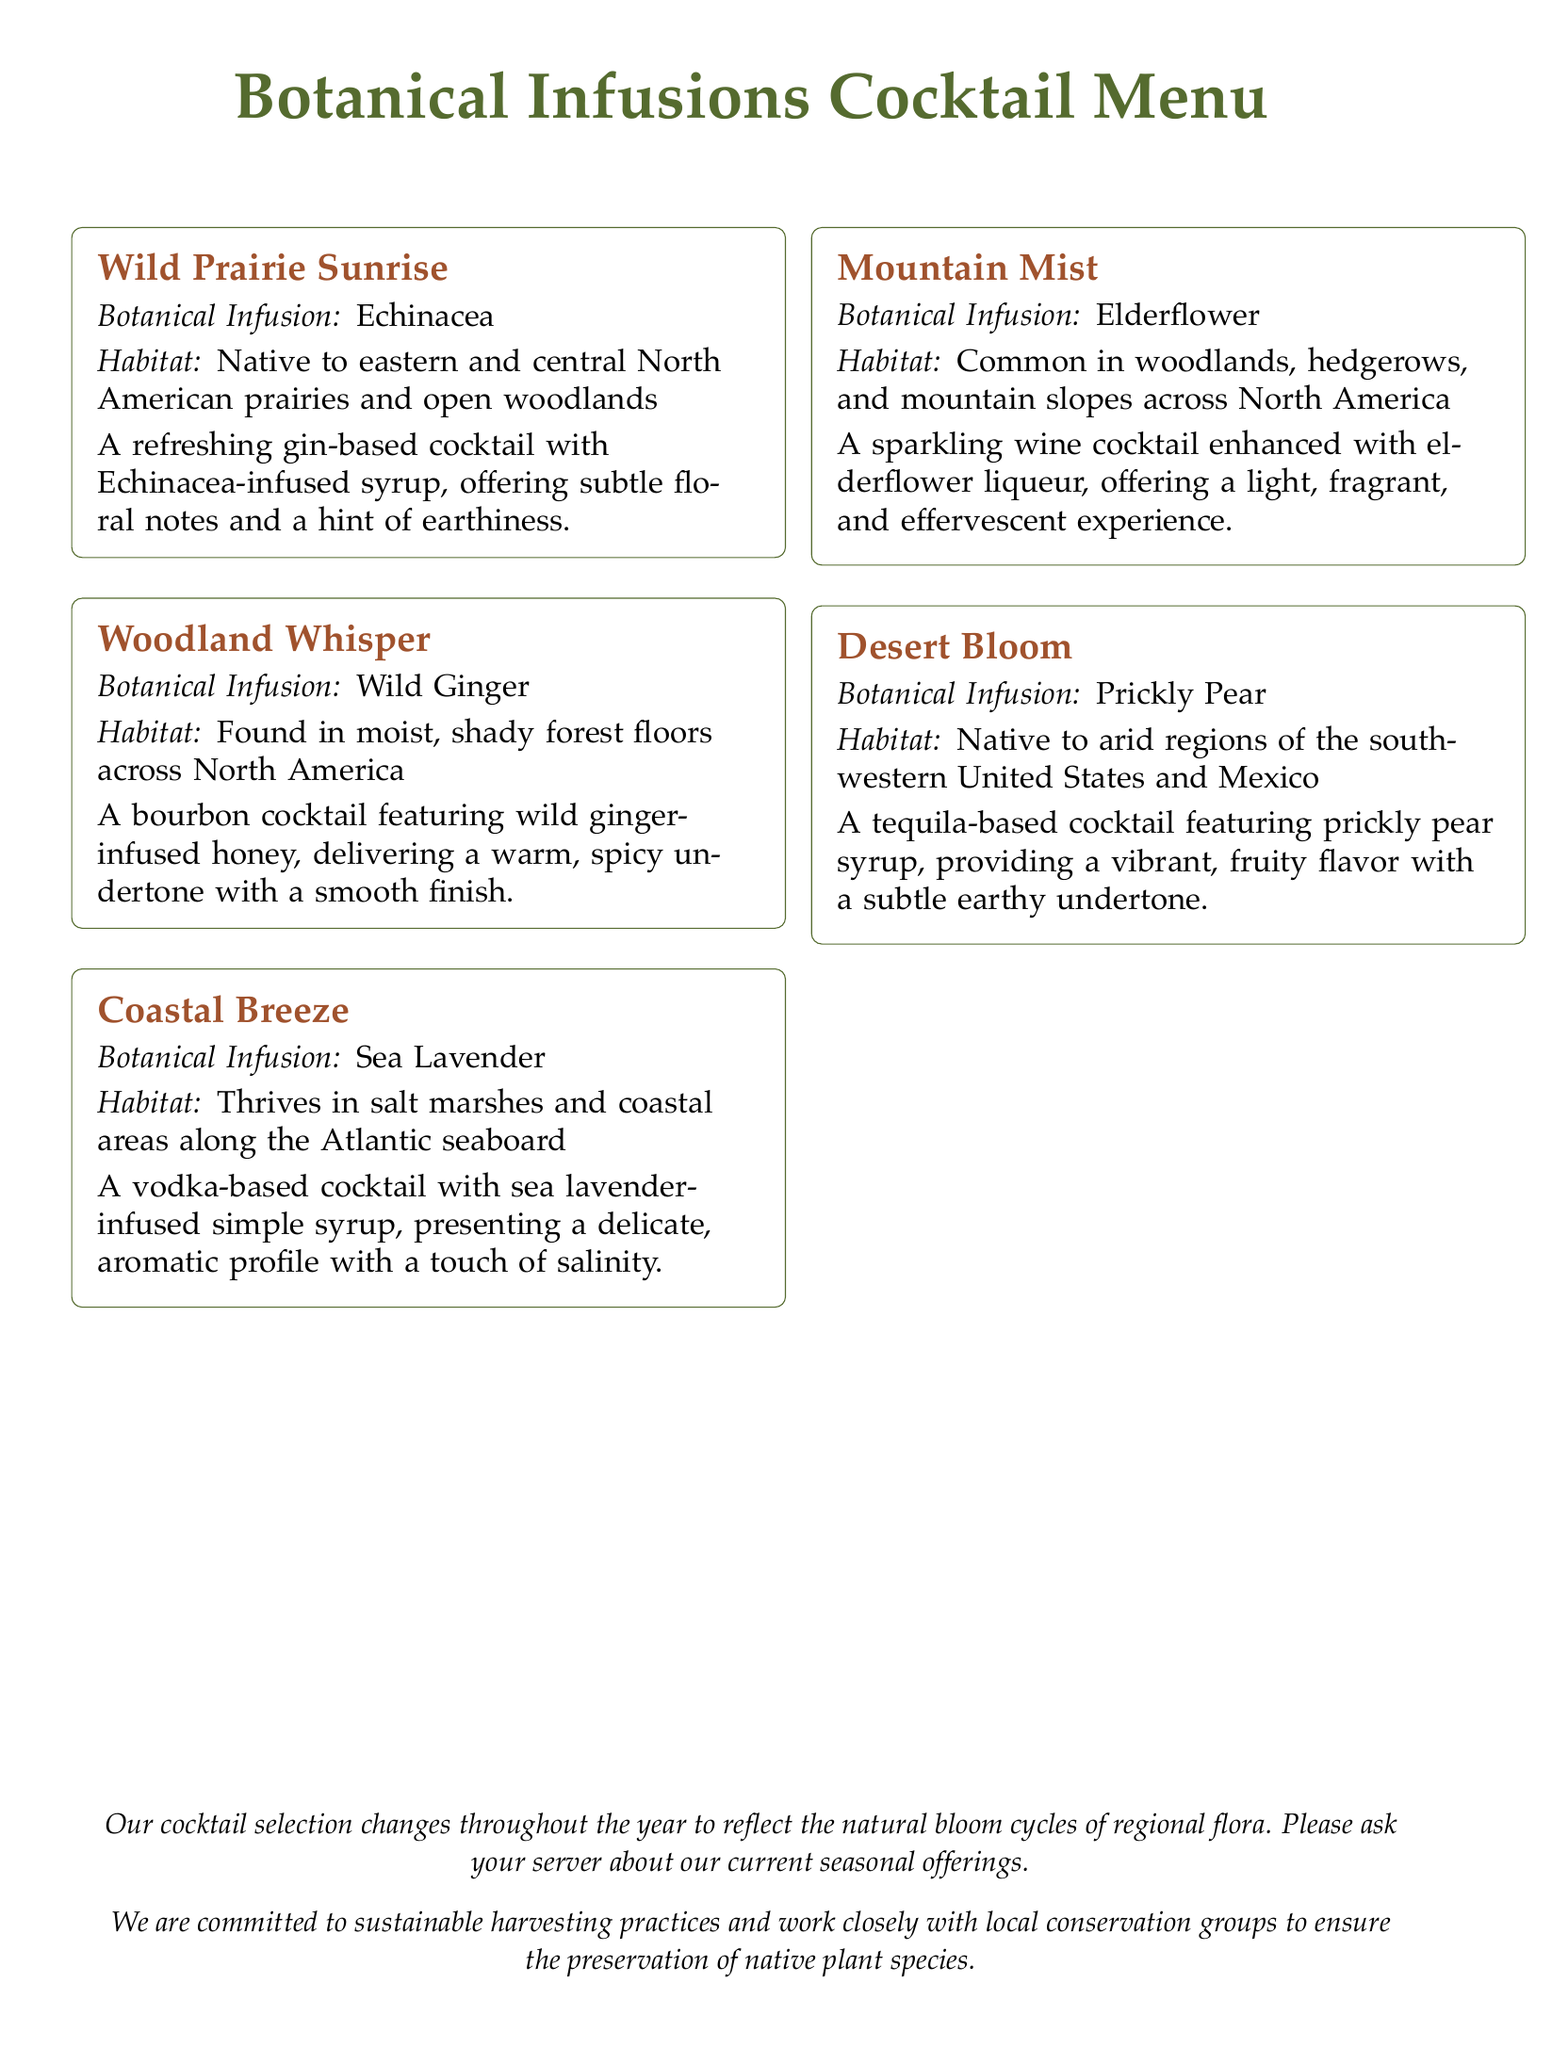What is the first cocktail listed? The first cocktail is named "Wild Prairie Sunrise" as per the rendered menu.
Answer: Wild Prairie Sunrise What botanical infusion is used in "Woodland Whisper"? "Woodland Whisper" features Wild Ginger infusion according to the document.
Answer: Wild Ginger Which cocktail contains Elderflower? The cocktail that contains Elderflower is "Mountain Mist" based on the information provided.
Answer: Mountain Mist How many cocktails are listed in total? The document presents a total of five cocktails in the menu section.
Answer: 5 What is the habitat of the plant used in "Coastal Breeze"? The plant used in "Coastal Breeze" thrives in salt marshes and coastal areas along the Atlantic seaboard according to the document.
Answer: Salt marshes and coastal areas along the Atlantic seaboard Which cocktail is based on a tequila spirit? The cocktail based on a tequila spirit is "Desert Bloom," as stated in the menu.
Answer: Desert Bloom What does the menu emphasize regarding harvesting practices? The menu highlights that they are committed to sustainable harvesting practices, suggesting an ecological focus.
Answer: Sustainable harvesting practices Which cocktail features Echinacea? "Wild Prairie Sunrise" features Echinacea infusion as listed on the menu.
Answer: Wild Prairie Sunrise What type of cocktail is "Mountain Mist"? "Mountain Mist" is a sparkling wine cocktail according to the details provided in the document.
Answer: Sparkling wine cocktail 